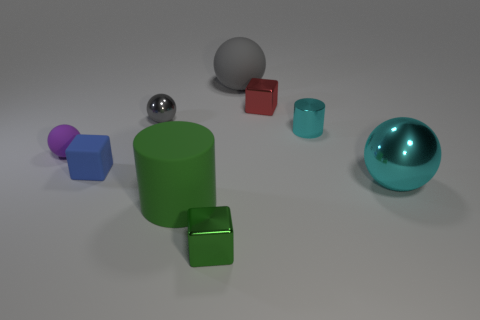Subtract 1 spheres. How many spheres are left? 3 Subtract all spheres. How many objects are left? 5 Add 1 cyan objects. How many objects exist? 10 Add 1 small balls. How many small balls are left? 3 Add 7 large balls. How many large balls exist? 9 Subtract 0 green spheres. How many objects are left? 9 Subtract all cyan metal spheres. Subtract all big cyan metal objects. How many objects are left? 7 